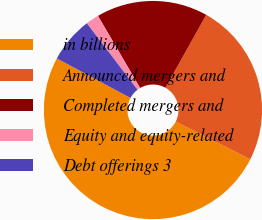<chart> <loc_0><loc_0><loc_500><loc_500><pie_chart><fcel>in billions<fcel>Announced mergers and<fcel>Completed mergers and<fcel>Equity and equity-related<fcel>Debt offerings 3<nl><fcel>50.38%<fcel>24.34%<fcel>16.53%<fcel>1.95%<fcel>6.79%<nl></chart> 